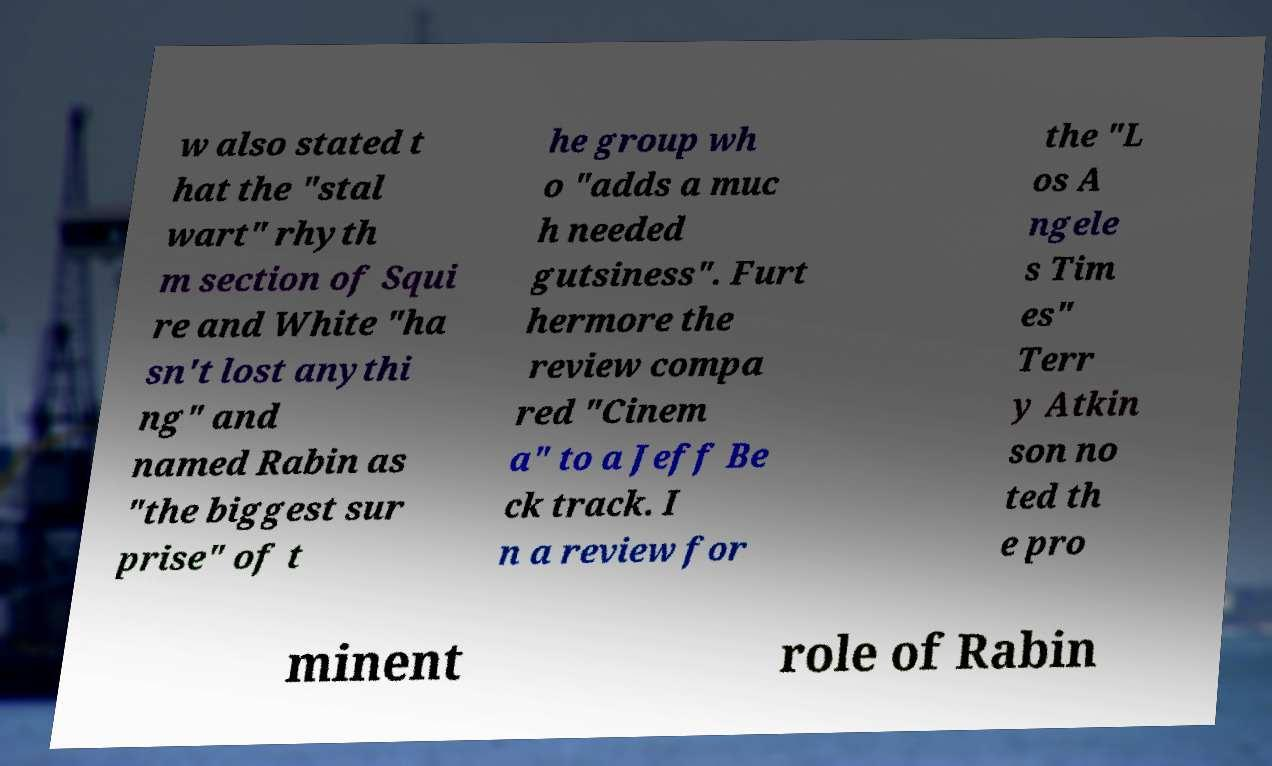For documentation purposes, I need the text within this image transcribed. Could you provide that? w also stated t hat the "stal wart" rhyth m section of Squi re and White "ha sn't lost anythi ng" and named Rabin as "the biggest sur prise" of t he group wh o "adds a muc h needed gutsiness". Furt hermore the review compa red "Cinem a" to a Jeff Be ck track. I n a review for the "L os A ngele s Tim es" Terr y Atkin son no ted th e pro minent role of Rabin 